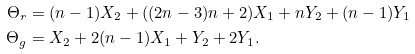Convert formula to latex. <formula><loc_0><loc_0><loc_500><loc_500>\Theta _ { r } & = ( n - 1 ) X _ { 2 } + ( ( 2 n - 3 ) n + 2 ) X _ { 1 } + n Y _ { 2 } + ( n - 1 ) Y _ { 1 } \\ \Theta _ { g } & = X _ { 2 } + 2 ( n - 1 ) X _ { 1 } + Y _ { 2 } + 2 Y _ { 1 } .</formula> 